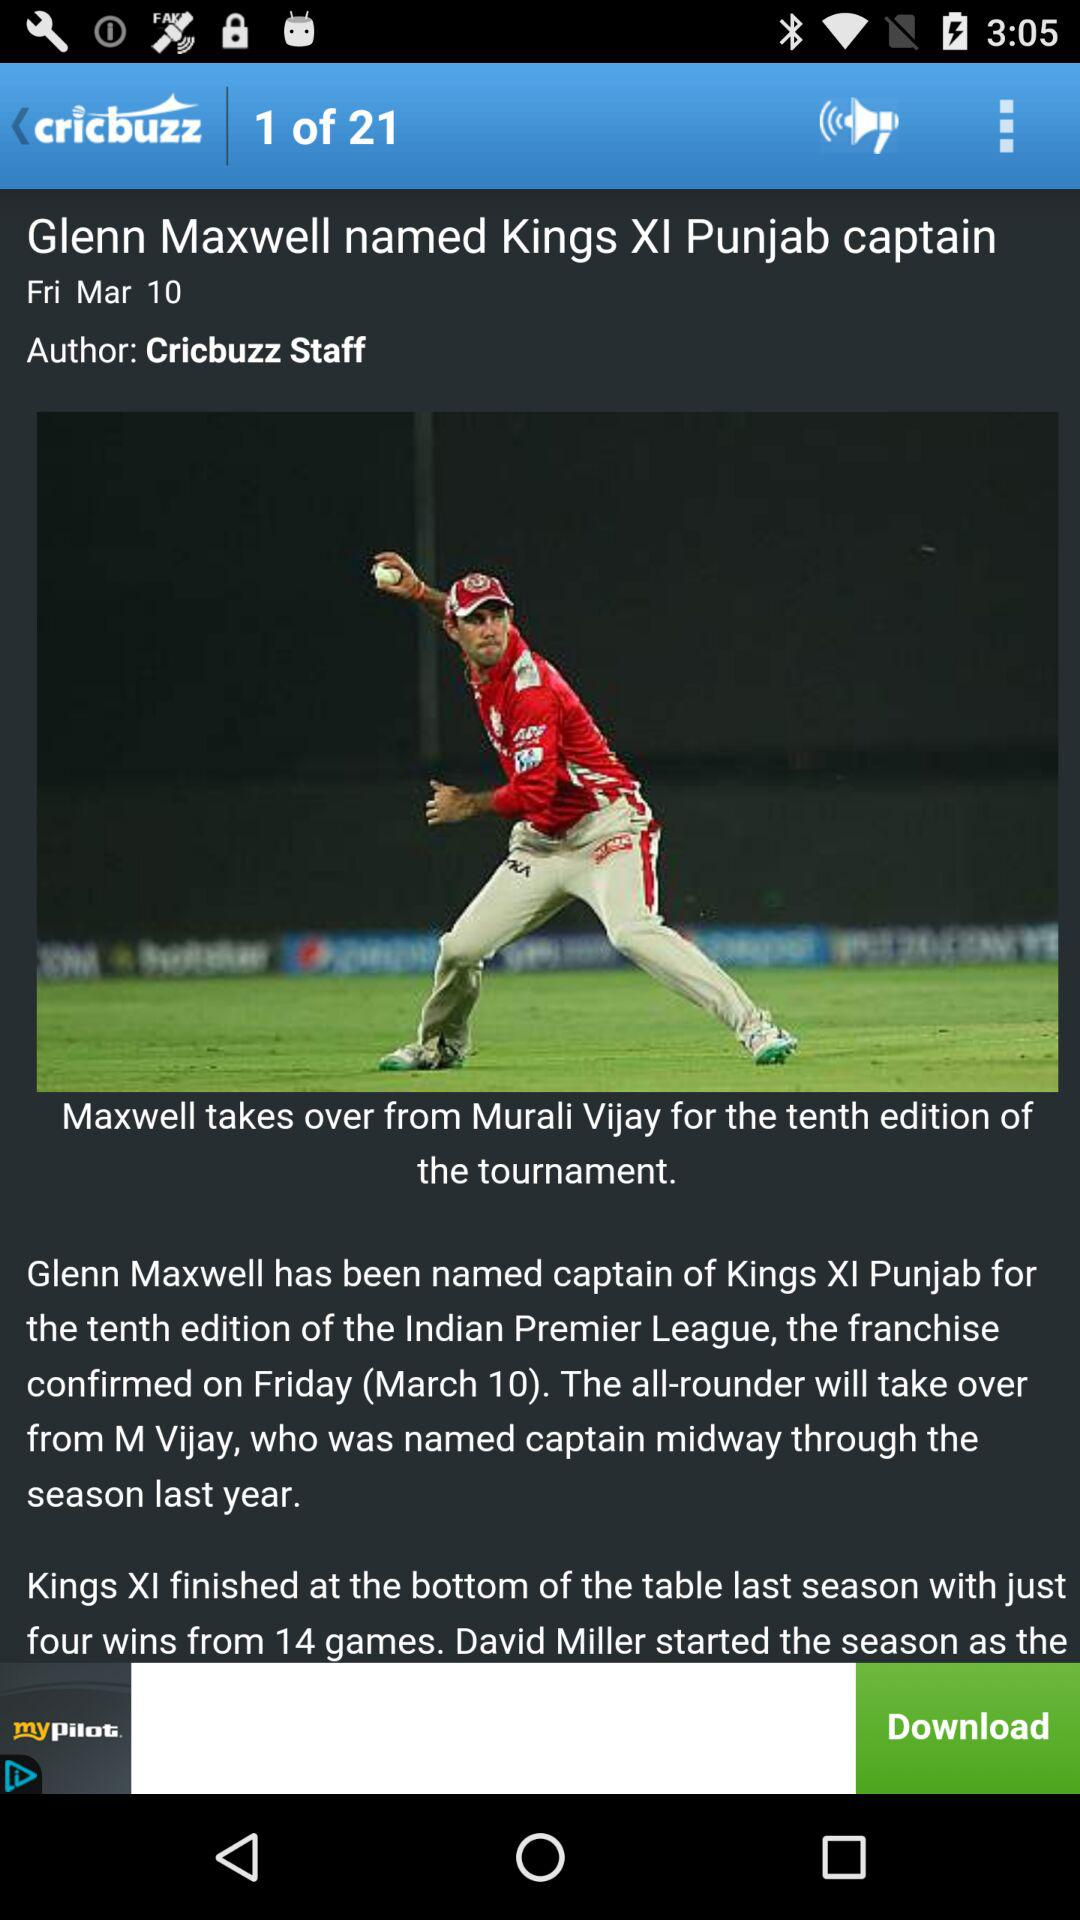What is the current count of the page number shown? The current count is 1. 